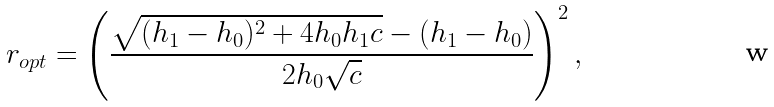<formula> <loc_0><loc_0><loc_500><loc_500>r _ { o p t } = \left ( \frac { \sqrt { ( h _ { 1 } - h _ { 0 } ) ^ { 2 } + 4 h _ { 0 } h _ { 1 } c } - ( h _ { 1 } - h _ { 0 } ) } { 2 h _ { 0 } \sqrt { c } } \right ) ^ { 2 } ,</formula> 